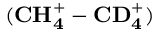Convert formula to latex. <formula><loc_0><loc_0><loc_500><loc_500>( C H _ { 4 } ^ { + } - C D _ { 4 } ^ { + } )</formula> 